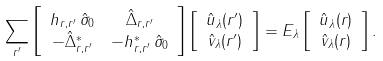<formula> <loc_0><loc_0><loc_500><loc_500>\sum _ { r ^ { \prime } } & \left [ \begin{array} { c c } { h } _ { r , r ^ { \prime } } \, \hat { \sigma } _ { 0 } & \hat { \Delta } _ { r , r ^ { \prime } } \\ - \hat { \Delta } ^ { \ast } _ { r , r ^ { \prime } } & - { h } ^ { \ast } _ { r , r ^ { \prime } } \, \hat { \sigma } _ { 0 } \end{array} \right ] \left [ \begin{array} { c } \hat { u } _ { \lambda } ( r ^ { \prime } ) \\ \hat { v } _ { \lambda } ( r ^ { \prime } ) \end{array} \right ] = E _ { \lambda } \left [ \begin{array} { c } \hat { u } _ { \lambda } ( r ) \\ \hat { v } _ { \lambda } ( r ) \end{array} \right ] .</formula> 